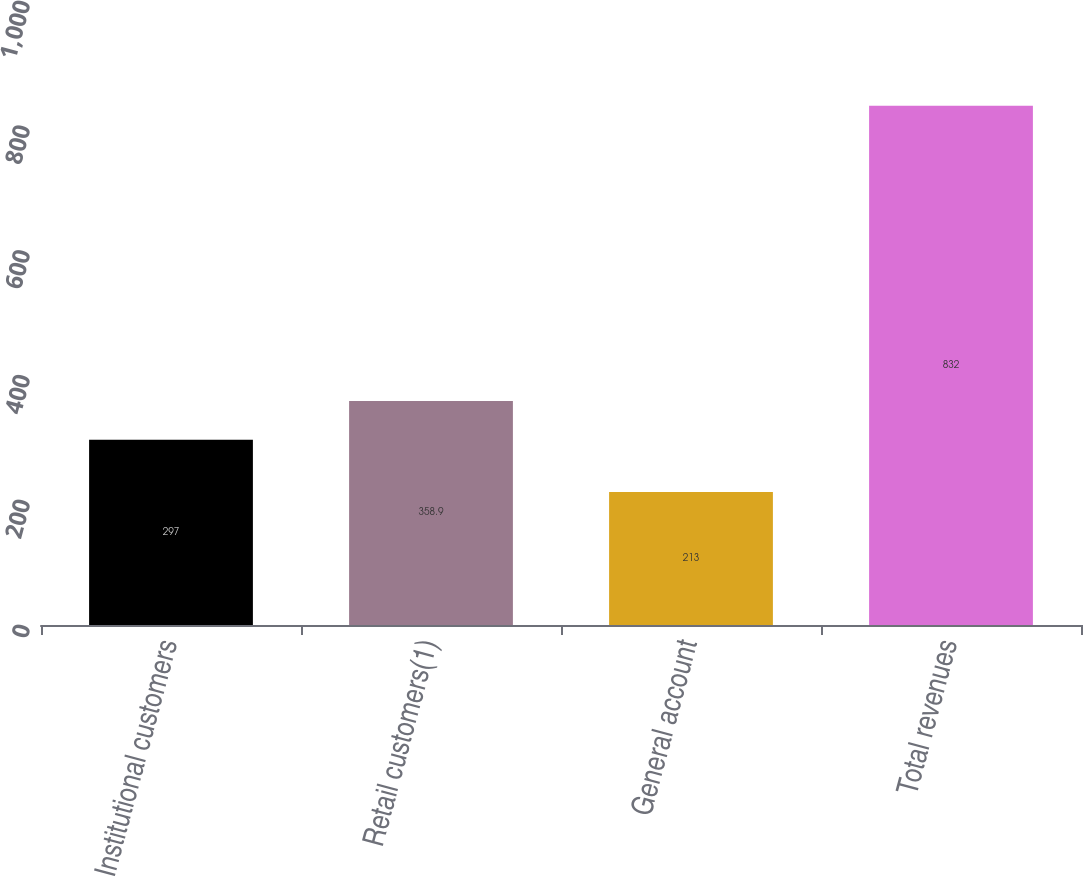Convert chart. <chart><loc_0><loc_0><loc_500><loc_500><bar_chart><fcel>Institutional customers<fcel>Retail customers(1)<fcel>General account<fcel>Total revenues<nl><fcel>297<fcel>358.9<fcel>213<fcel>832<nl></chart> 